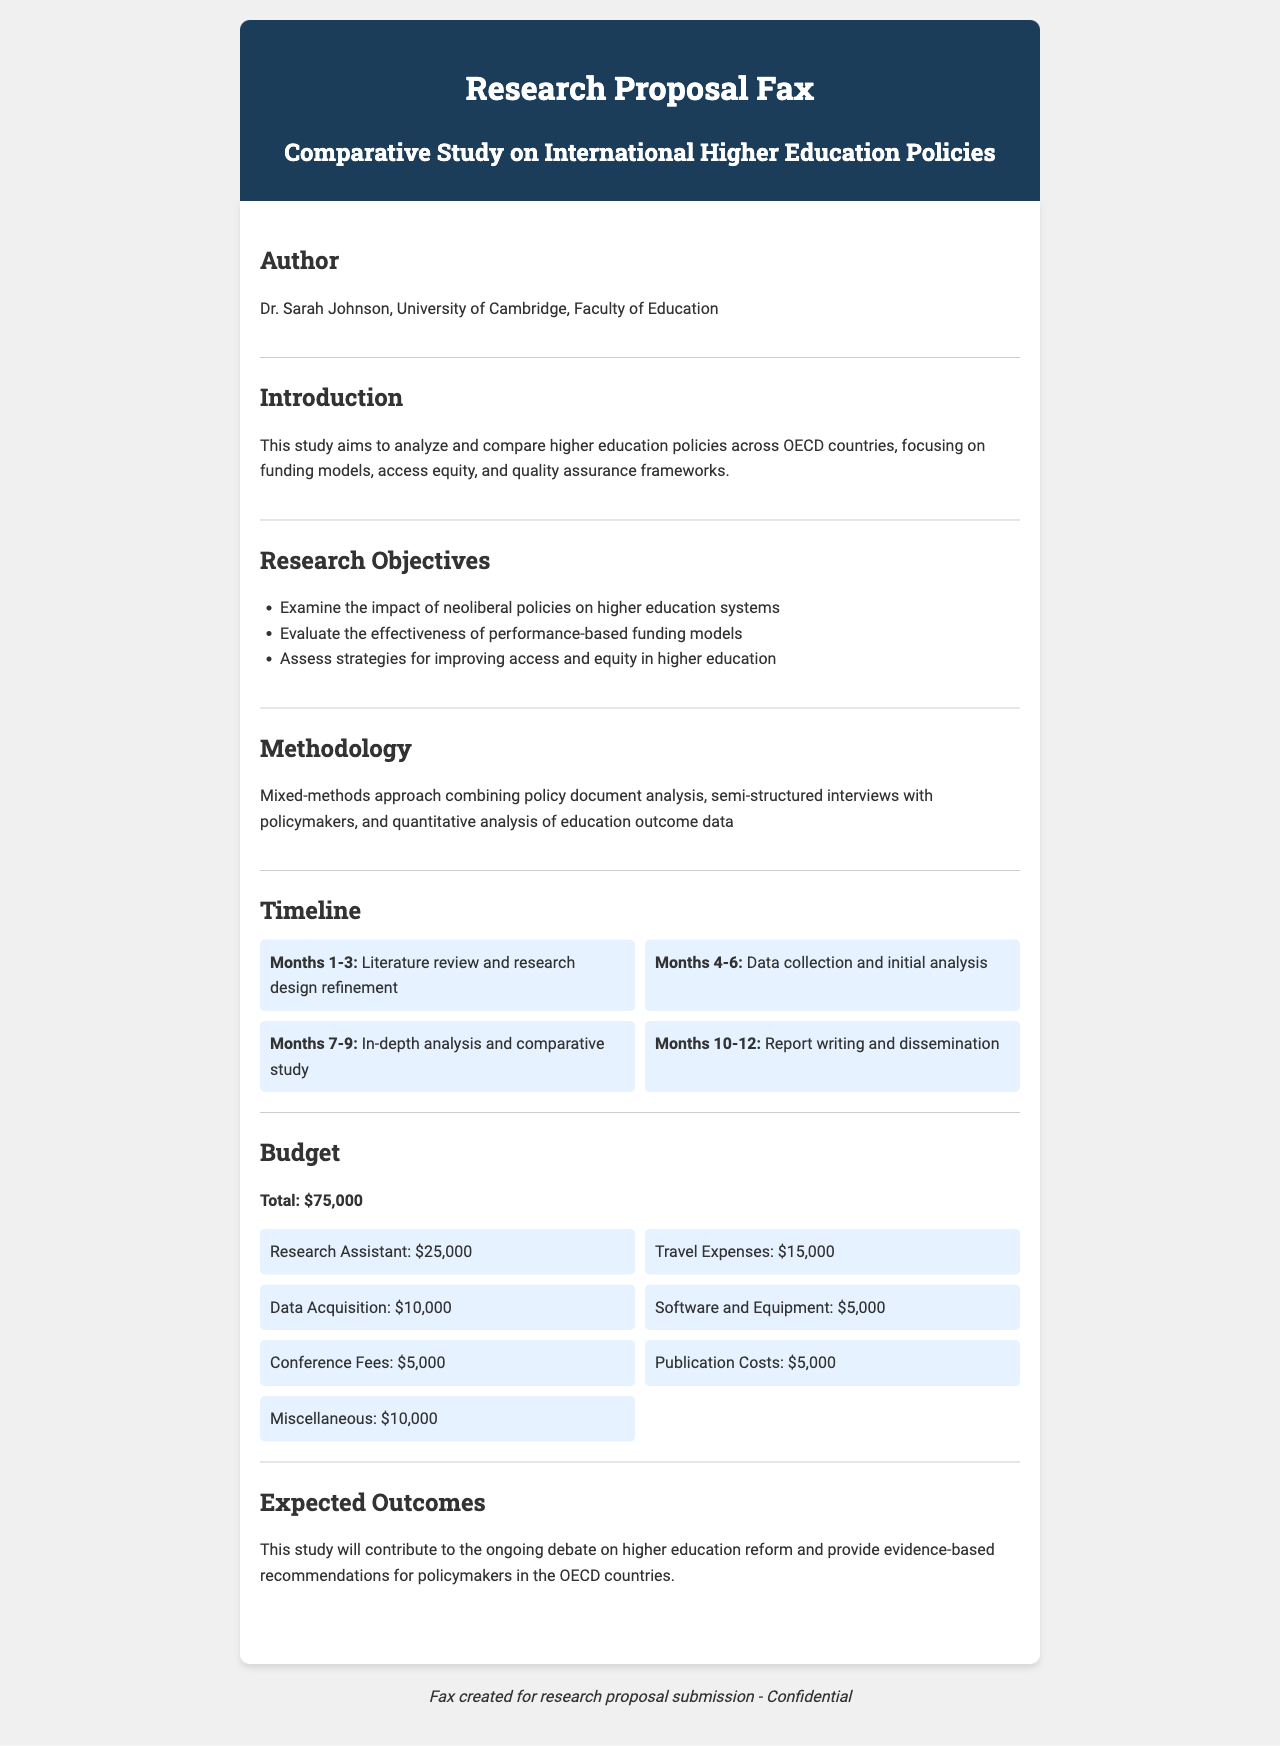What is the title of the research proposal? The title is explicitly stated in the document as "Comparative Study on International Higher Education Policies."
Answer: Comparative Study on International Higher Education Policies Who is the author of the study? The author is mentioned in the document; her name and affiliation are provided.
Answer: Dr. Sarah Johnson, University of Cambridge What is the total budget for the research? The total budget is stated clearly in the budget section of the document as the overall expense for the study.
Answer: $75,000 What is the first task in the timeline? The timeline outlines activities in chronological order, and the first task is detailed in the Months 1-3 section.
Answer: Literature review and research design refinement Which methodology is being utilized for the study? The methodology section provides an overview of the research approach that will be implemented.
Answer: Mixed-methods approach How much is allocated for travel expenses? The budget breakdown specifies the allocation for travel expenses in the overall budget.
Answer: $15,000 What is one of the expected outcomes of the study? The expected outcomes section summarizes what the study aims to achieve, specifically in terms of contributions to policy discussions.
Answer: Evidence-based recommendations for policymakers What is the duration of the entire research project? The timeline details the duration of tasks planned for the research, indicating the project's overall length.
Answer: 12 months What type of research design is indicated in the proposal? The introduction and methodology sections suggest the type of research design being proposed.
Answer: Comparative study 